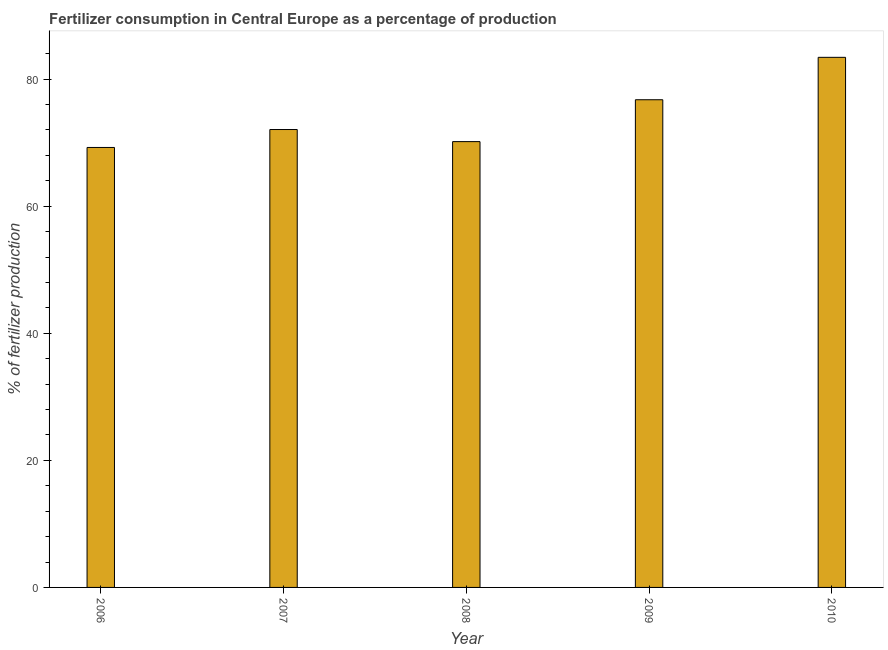Does the graph contain any zero values?
Offer a terse response. No. What is the title of the graph?
Keep it short and to the point. Fertilizer consumption in Central Europe as a percentage of production. What is the label or title of the X-axis?
Offer a terse response. Year. What is the label or title of the Y-axis?
Ensure brevity in your answer.  % of fertilizer production. What is the amount of fertilizer consumption in 2007?
Your answer should be compact. 72.07. Across all years, what is the maximum amount of fertilizer consumption?
Provide a succinct answer. 83.43. Across all years, what is the minimum amount of fertilizer consumption?
Make the answer very short. 69.24. In which year was the amount of fertilizer consumption minimum?
Your response must be concise. 2006. What is the sum of the amount of fertilizer consumption?
Your answer should be very brief. 371.65. What is the difference between the amount of fertilizer consumption in 2009 and 2010?
Provide a short and direct response. -6.67. What is the average amount of fertilizer consumption per year?
Offer a very short reply. 74.33. What is the median amount of fertilizer consumption?
Your answer should be very brief. 72.07. What is the ratio of the amount of fertilizer consumption in 2006 to that in 2007?
Keep it short and to the point. 0.96. Is the amount of fertilizer consumption in 2008 less than that in 2009?
Keep it short and to the point. Yes. Is the difference between the amount of fertilizer consumption in 2009 and 2010 greater than the difference between any two years?
Give a very brief answer. No. What is the difference between the highest and the second highest amount of fertilizer consumption?
Your answer should be very brief. 6.67. What is the difference between the highest and the lowest amount of fertilizer consumption?
Keep it short and to the point. 14.18. How many bars are there?
Provide a short and direct response. 5. How many years are there in the graph?
Make the answer very short. 5. Are the values on the major ticks of Y-axis written in scientific E-notation?
Ensure brevity in your answer.  No. What is the % of fertilizer production in 2006?
Ensure brevity in your answer.  69.24. What is the % of fertilizer production in 2007?
Offer a terse response. 72.07. What is the % of fertilizer production of 2008?
Your response must be concise. 70.16. What is the % of fertilizer production in 2009?
Ensure brevity in your answer.  76.75. What is the % of fertilizer production of 2010?
Your answer should be compact. 83.43. What is the difference between the % of fertilizer production in 2006 and 2007?
Provide a succinct answer. -2.82. What is the difference between the % of fertilizer production in 2006 and 2008?
Your answer should be compact. -0.92. What is the difference between the % of fertilizer production in 2006 and 2009?
Your answer should be very brief. -7.51. What is the difference between the % of fertilizer production in 2006 and 2010?
Make the answer very short. -14.18. What is the difference between the % of fertilizer production in 2007 and 2008?
Offer a very short reply. 1.9. What is the difference between the % of fertilizer production in 2007 and 2009?
Your response must be concise. -4.69. What is the difference between the % of fertilizer production in 2007 and 2010?
Offer a terse response. -11.36. What is the difference between the % of fertilizer production in 2008 and 2009?
Provide a succinct answer. -6.59. What is the difference between the % of fertilizer production in 2008 and 2010?
Your answer should be compact. -13.26. What is the difference between the % of fertilizer production in 2009 and 2010?
Offer a terse response. -6.68. What is the ratio of the % of fertilizer production in 2006 to that in 2009?
Provide a short and direct response. 0.9. What is the ratio of the % of fertilizer production in 2006 to that in 2010?
Your answer should be compact. 0.83. What is the ratio of the % of fertilizer production in 2007 to that in 2008?
Provide a succinct answer. 1.03. What is the ratio of the % of fertilizer production in 2007 to that in 2009?
Make the answer very short. 0.94. What is the ratio of the % of fertilizer production in 2007 to that in 2010?
Give a very brief answer. 0.86. What is the ratio of the % of fertilizer production in 2008 to that in 2009?
Provide a short and direct response. 0.91. What is the ratio of the % of fertilizer production in 2008 to that in 2010?
Offer a very short reply. 0.84. 